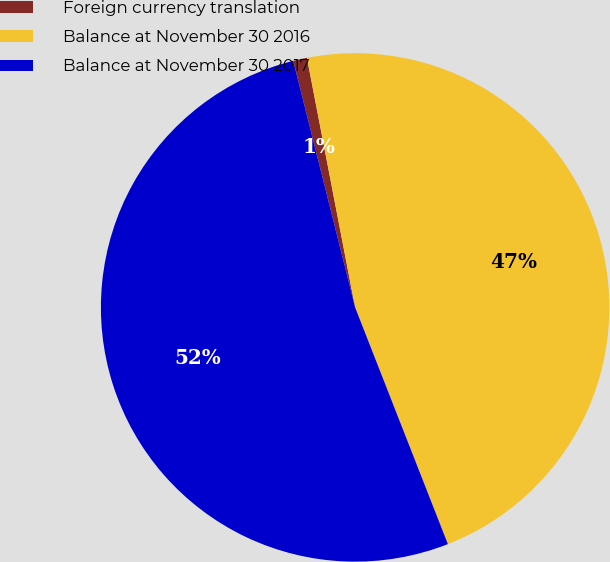Convert chart. <chart><loc_0><loc_0><loc_500><loc_500><pie_chart><fcel>Foreign currency translation<fcel>Balance at November 30 2016<fcel>Balance at November 30 2017<nl><fcel>0.88%<fcel>47.09%<fcel>52.03%<nl></chart> 